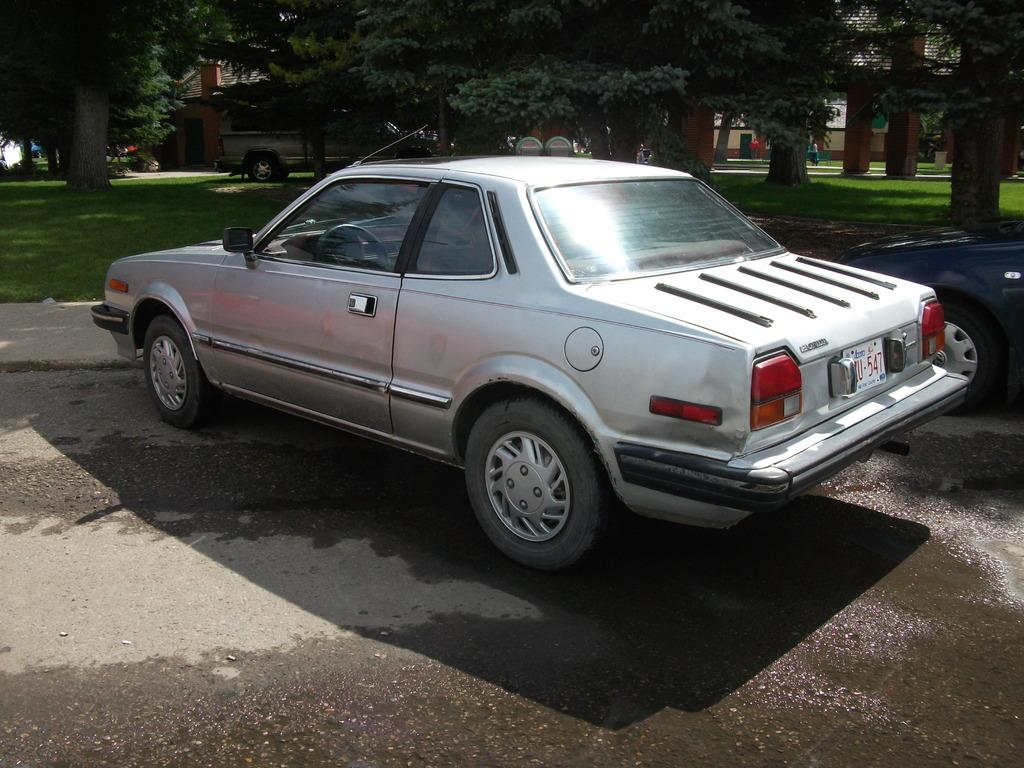What types of objects are present in the image? There are vehicles in the image. What can be seen in the distance behind the vehicles? There are trees and buildings in the background of the image. What is the ground covered with in the image? The ground is covered with grass in the image. What type of bells can be heard ringing in the image? There are no bells present in the image, and therefore no sound can be heard. 